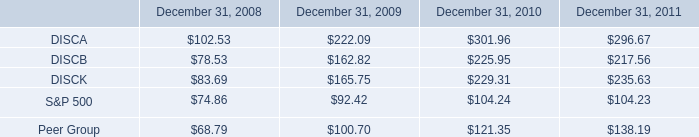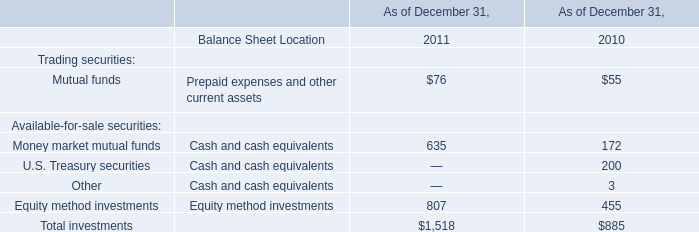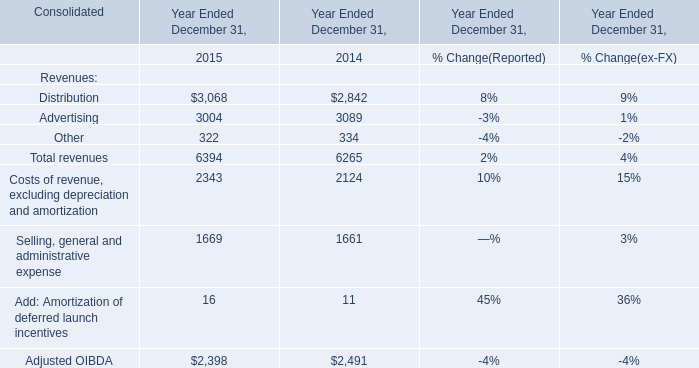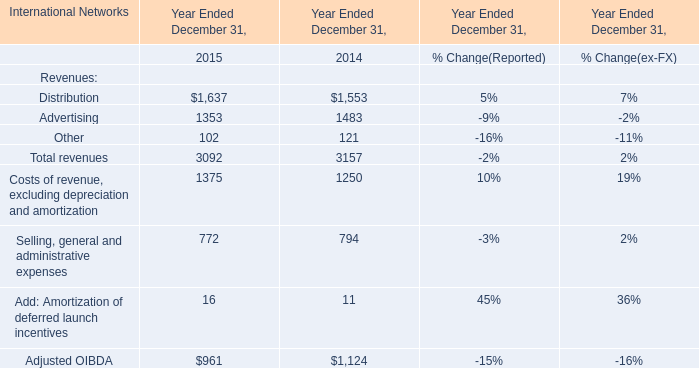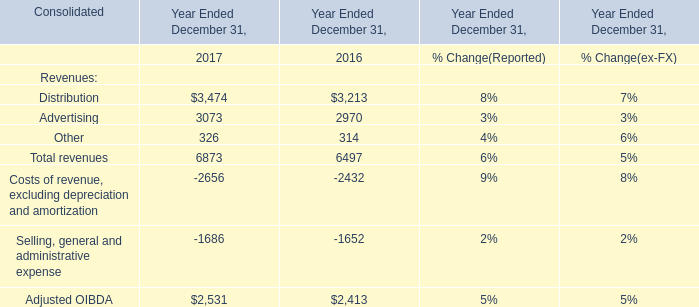What's the average of Distribution of Year Ended December 31, 2015, and Advertising of Year Ended December 31, 2017 ? 
Computations: ((1637.0 + 3073.0) / 2)
Answer: 2355.0. 